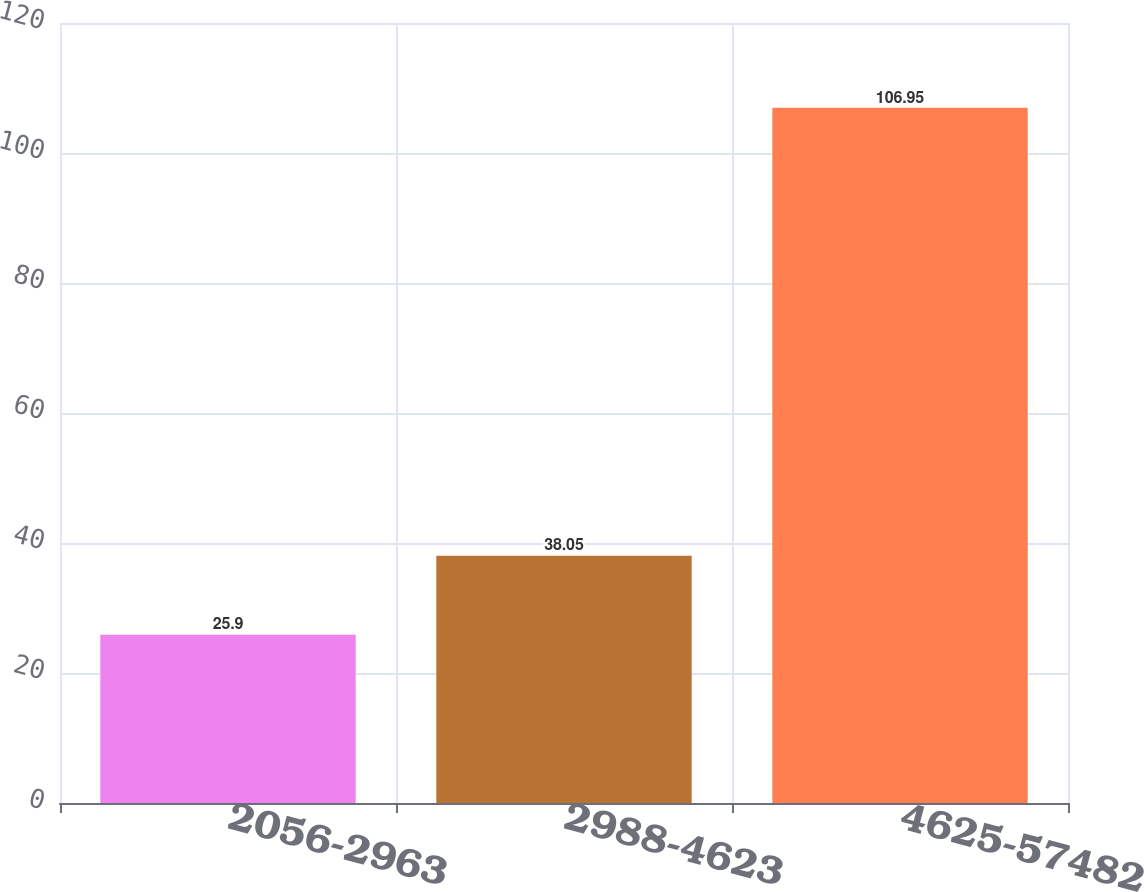Convert chart. <chart><loc_0><loc_0><loc_500><loc_500><bar_chart><fcel>2056-2963<fcel>2988-4623<fcel>4625-57482<nl><fcel>25.9<fcel>38.05<fcel>106.95<nl></chart> 